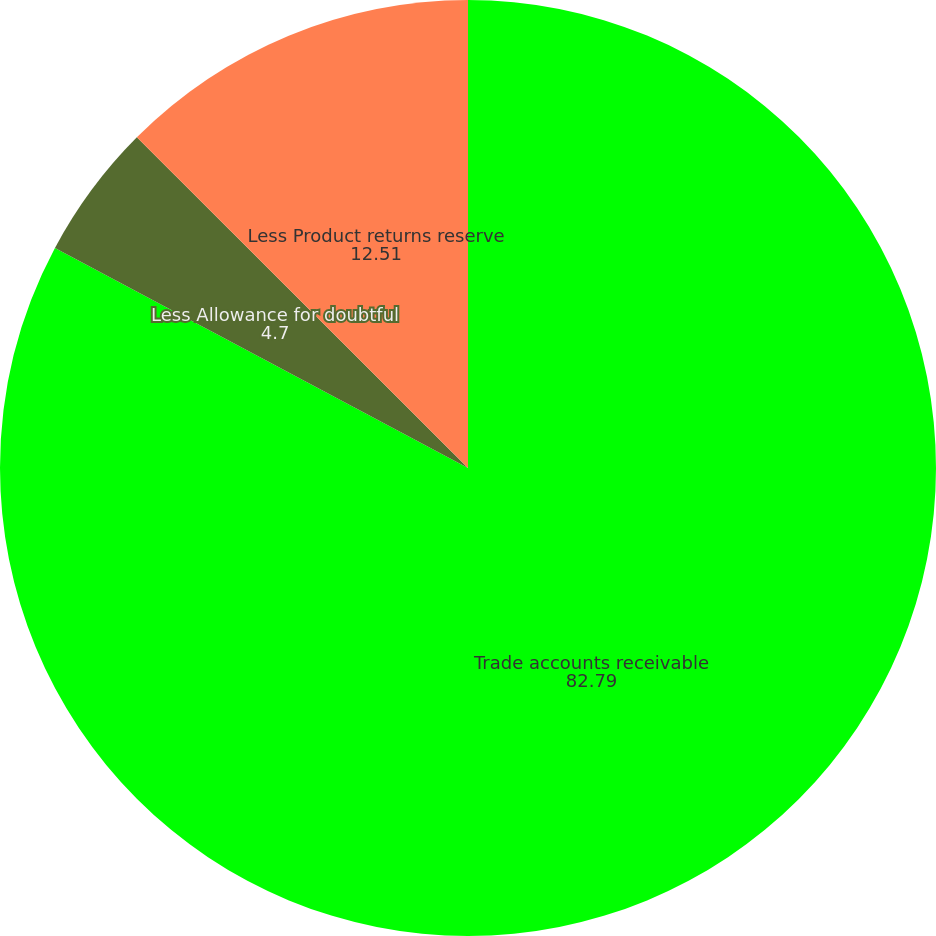Convert chart. <chart><loc_0><loc_0><loc_500><loc_500><pie_chart><fcel>Trade accounts receivable<fcel>Less Allowance for doubtful<fcel>Less Product returns reserve<nl><fcel>82.79%<fcel>4.7%<fcel>12.51%<nl></chart> 